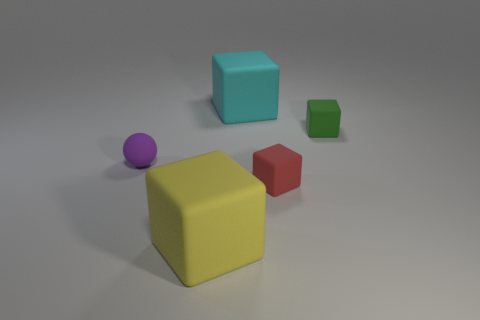How many other things are made of the same material as the small purple object?
Offer a very short reply. 4. Are there any other tiny purple objects that have the same material as the tiny purple object?
Ensure brevity in your answer.  No. What number of small blocks are there?
Your answer should be very brief. 2. How many spheres are either purple matte objects or small green matte objects?
Ensure brevity in your answer.  1. There is another rubber object that is the same size as the cyan matte object; what color is it?
Your response must be concise. Yellow. What number of rubber objects are both to the left of the tiny green matte block and behind the yellow thing?
Your answer should be compact. 3. What is the material of the tiny green thing?
Your response must be concise. Rubber. What number of things are red things or green metal cylinders?
Make the answer very short. 1. Is the size of the rubber thing behind the green thing the same as the rubber object to the right of the red matte thing?
Keep it short and to the point. No. What number of other objects are the same size as the red rubber thing?
Give a very brief answer. 2. 